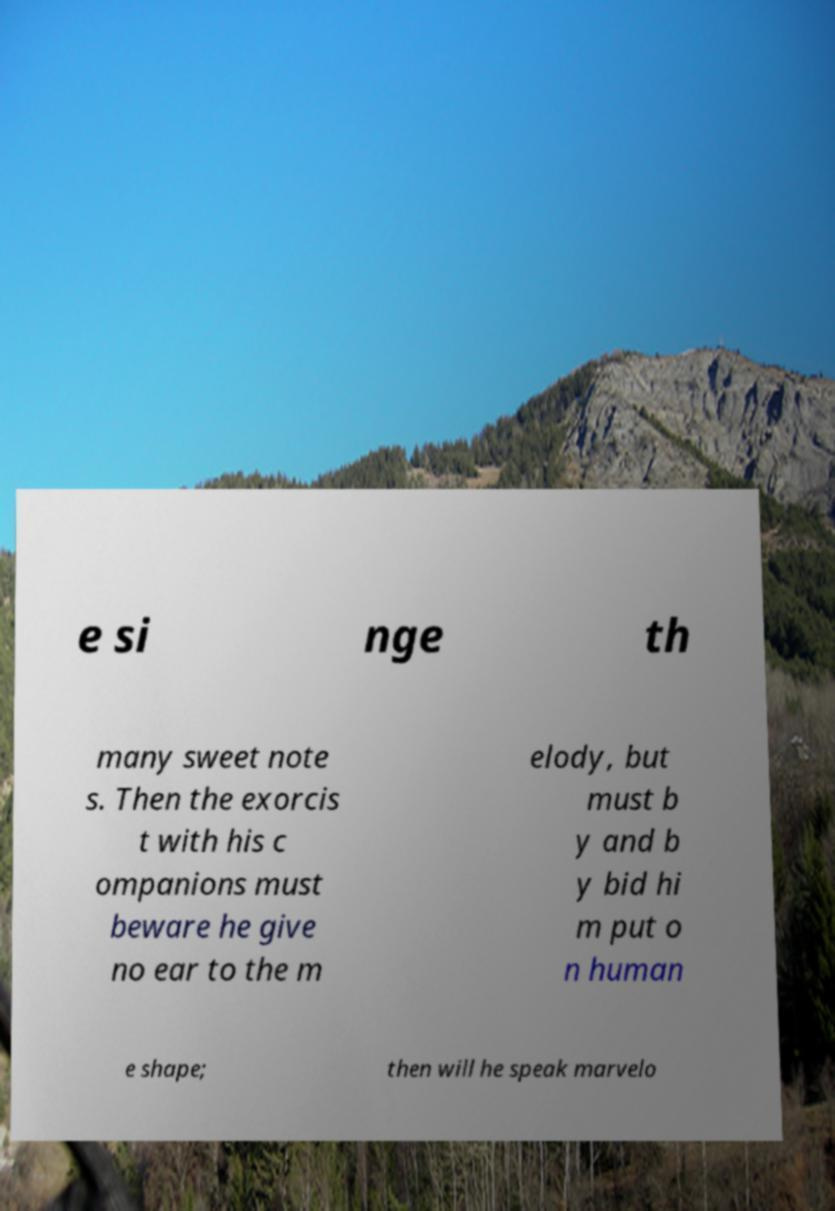I need the written content from this picture converted into text. Can you do that? e si nge th many sweet note s. Then the exorcis t with his c ompanions must beware he give no ear to the m elody, but must b y and b y bid hi m put o n human e shape; then will he speak marvelo 